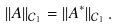<formula> <loc_0><loc_0><loc_500><loc_500>| | A | | _ { \mathcal { C } _ { 1 } } = | | A ^ { * } | | _ { \mathcal { C } _ { 1 } } \, .</formula> 